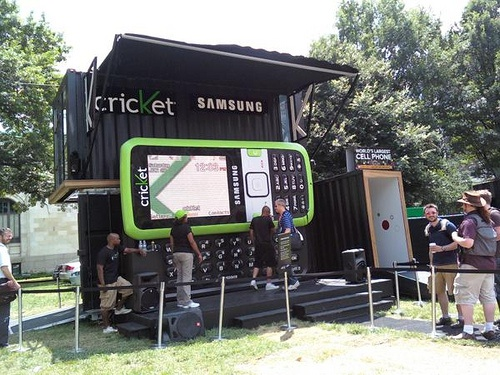Describe the objects in this image and their specific colors. I can see cell phone in teal, lightgray, black, lightgreen, and darkgray tones, people in teal, darkgray, gray, black, and lightgray tones, people in teal, black, gray, and darkgray tones, people in teal, black, gray, and darkgray tones, and people in teal, black, and gray tones in this image. 